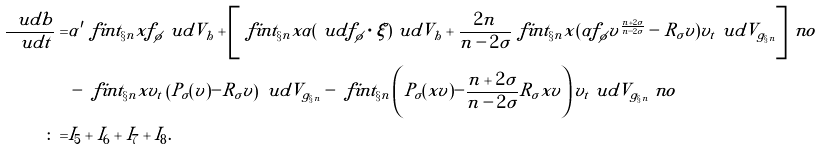<formula> <loc_0><loc_0><loc_500><loc_500>\frac { \ u d b } { \ u d t } = & \alpha ^ { \prime } \ f i n t _ { \S n } x f _ { \phi } \ u d V _ { h } + \left [ \ f i n t _ { \S n } x \alpha ( \ u d f _ { \phi } \cdot \xi ) \ u d V _ { h } + \frac { 2 n } { n - 2 \sigma } \ f i n t _ { \S n } x ( \alpha f _ { \phi } v ^ { \frac { n + 2 \sigma } { n - 2 \sigma } } - R _ { \sigma } v ) v _ { t } \ u d V _ { g _ { \S n } } \right ] \ n o \\ & - \ f i n t _ { \S n } x v _ { t } \left ( P _ { \sigma } ( v ) - R _ { \sigma } v \right ) \ u d V _ { g _ { \S n } } - \ f i n t _ { \S n } \left ( P _ { \sigma } ( x v ) - \frac { n + 2 \sigma } { n - 2 \sigma } R _ { \sigma } x v \right ) v _ { t } \ u d V _ { g _ { \S n } } \ n o \\ \colon = & I _ { 5 } + I _ { 6 } + I _ { 7 } + I _ { 8 } .</formula> 